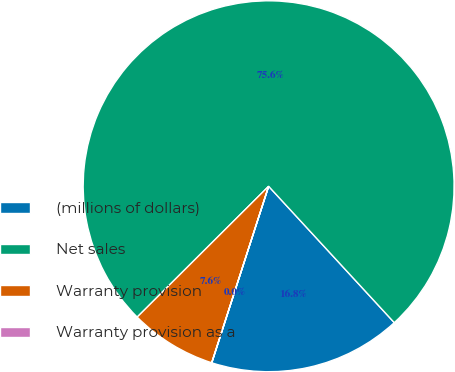Convert chart. <chart><loc_0><loc_0><loc_500><loc_500><pie_chart><fcel>(millions of dollars)<fcel>Net sales<fcel>Warranty provision<fcel>Warranty provision as a<nl><fcel>16.81%<fcel>75.62%<fcel>7.57%<fcel>0.01%<nl></chart> 